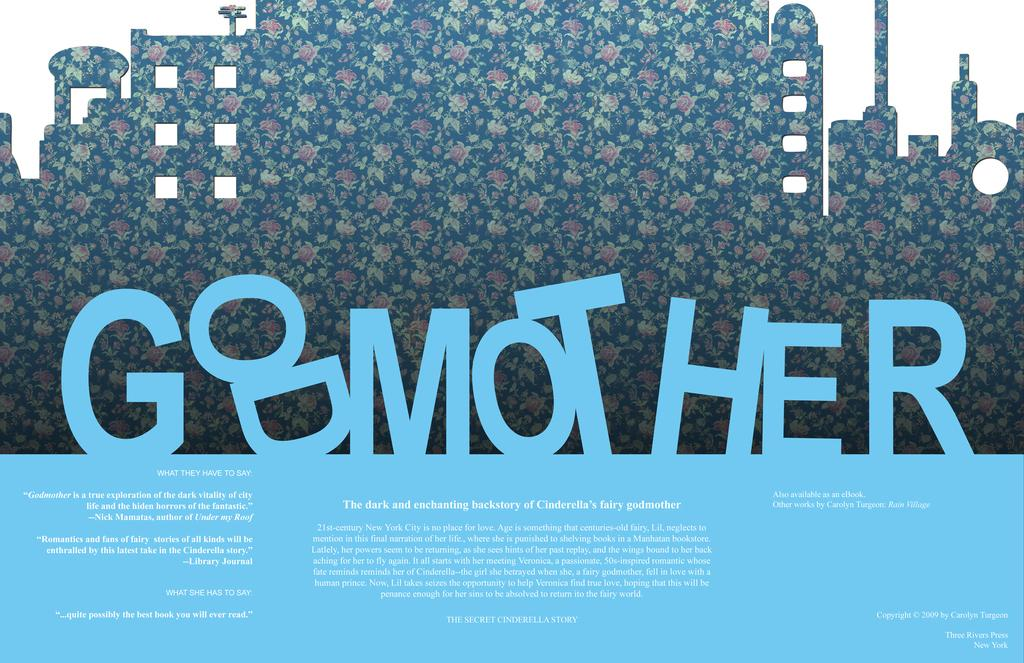What is present on the poster in the image? There is a poster in the image. What type of information is featured on the poster? There are words and numbers on the poster. What is the weather like in the image? The provided facts do not mention any information about the weather in the image. How does the poster move around in the image? The poster does not move around in the image; it is stationary. 